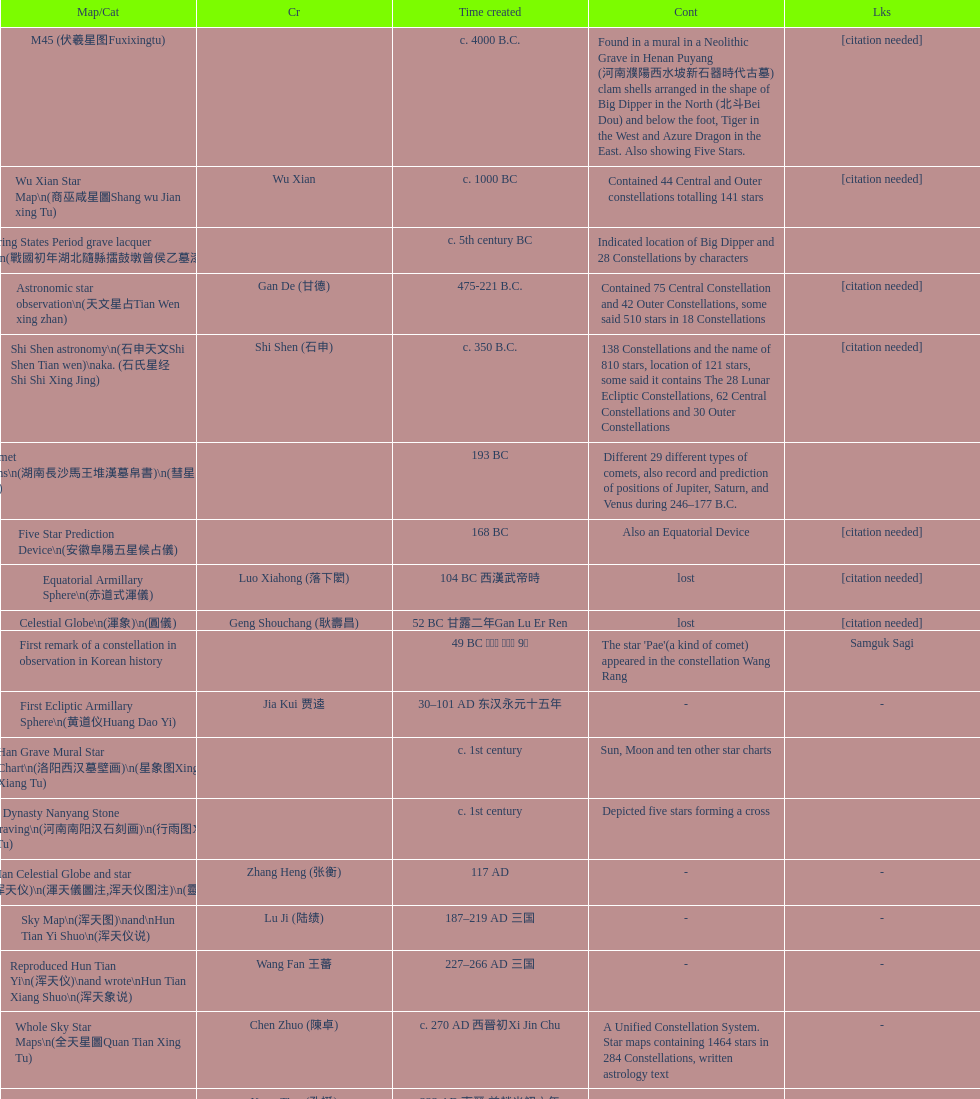When was the first map or catalog created? C. 4000 b.c. 